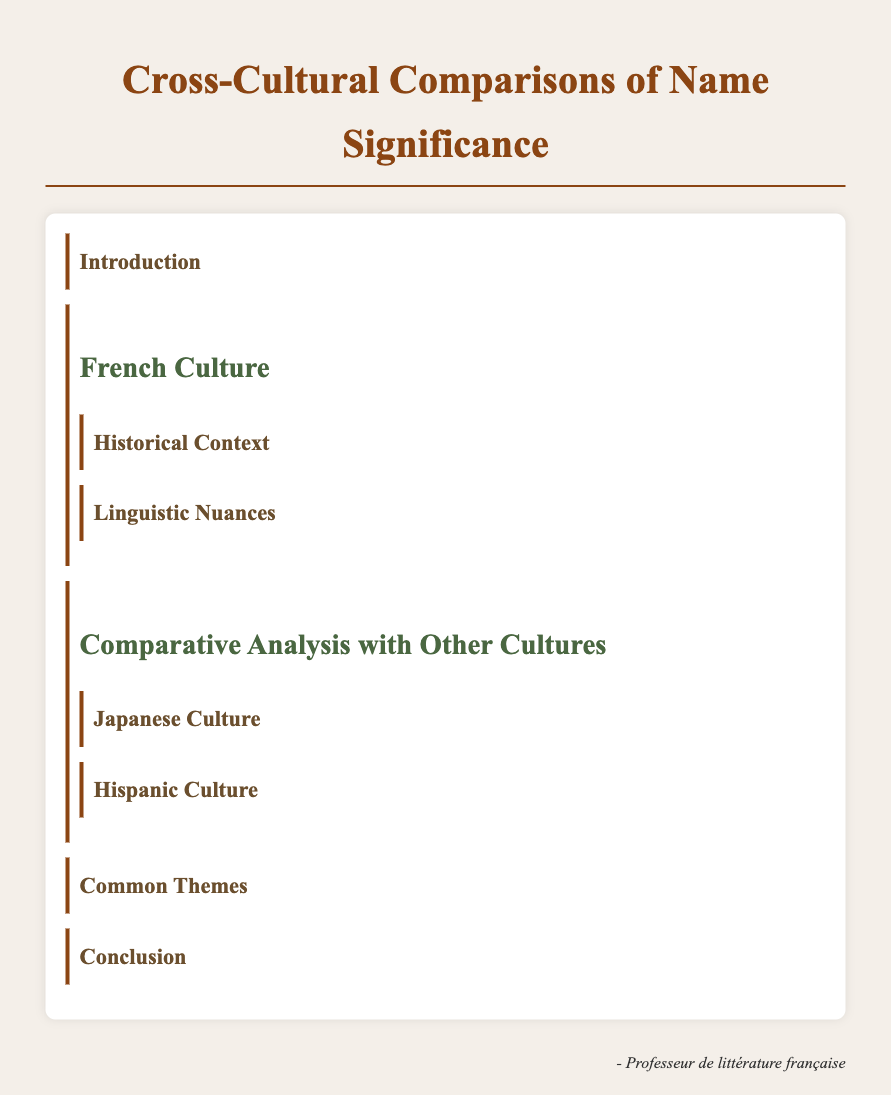What is the title of the document? The title is displayed prominently at the top of the document, indicating its focus on names.
Answer: Cross-Cultural Comparisons of Name Significance What is an example of a French name derived from a saint? The document mentions specific examples of names from French culture, providing a historical context.
Answer: Antoine What does 'Haruki' mean in Japanese culture? The meaning of this name is included in the section discussing Japanese culture, highlighting its significance in nature.
Answer: spring child What are Spanish naming customs typically include? This question is related to the information provided in the comparative analysis of Hispanic culture.
Answer: both paternal and maternal surnames What are two factors that names signify across cultures? This information is encapsulated in the section discussing common themes across different cultures.
Answer: social status, lineage Which culture uses gendered forms for names? The document specifies linguistic nuances related to gender in names within certain cultures.
Answer: French culture 